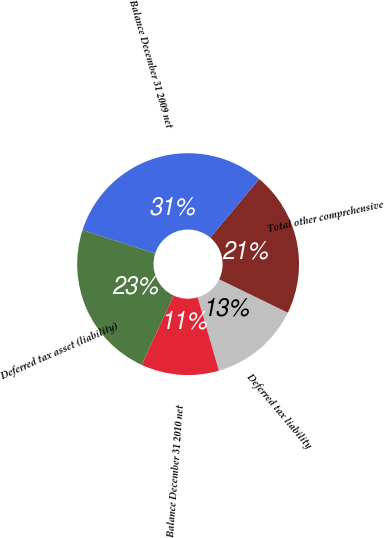Convert chart. <chart><loc_0><loc_0><loc_500><loc_500><pie_chart><fcel>Deferred tax liability<fcel>Total other comprehensive<fcel>Balance December 31 2009 net<fcel>Deferred tax asset (liability)<fcel>Balance December 31 2010 net<nl><fcel>13.31%<fcel>21.13%<fcel>31.12%<fcel>23.11%<fcel>11.33%<nl></chart> 